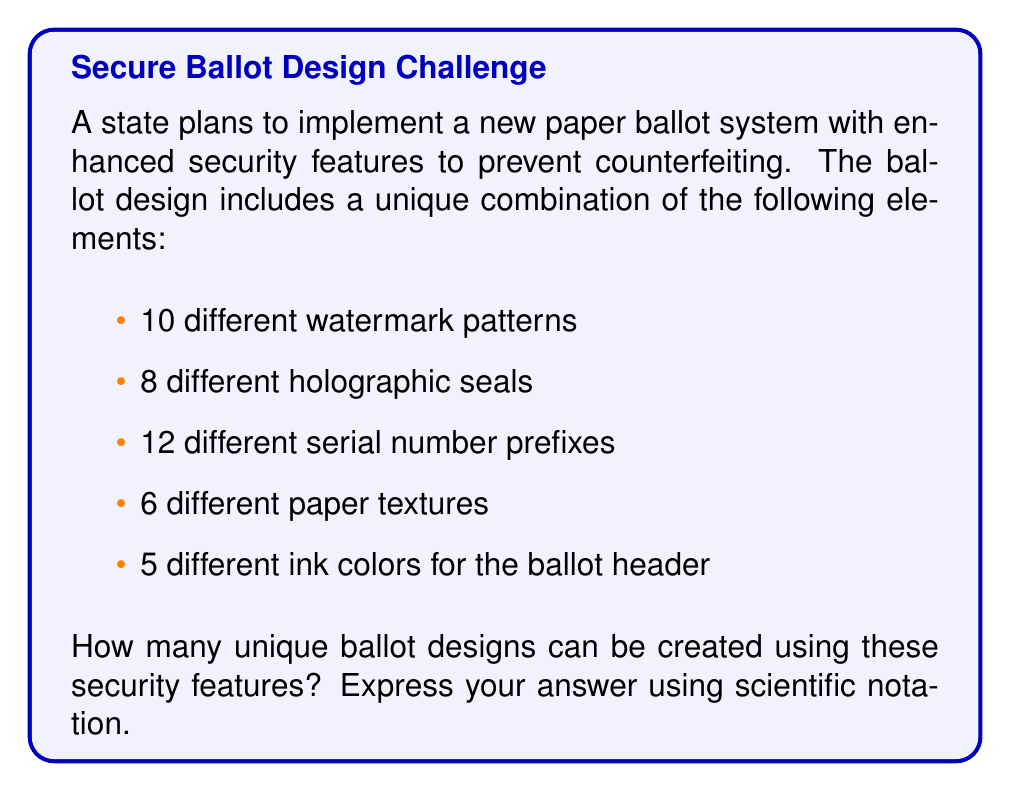Could you help me with this problem? To solve this problem, we'll use the multiplication principle of counting. Since each security feature can be chosen independently of the others, we multiply the number of options for each feature:

1. Number of watermark patterns: 10
2. Number of holographic seals: 8
3. Number of serial number prefixes: 12
4. Number of paper textures: 6
5. Number of ink colors for the header: 5

Total number of unique combinations:

$$ 10 \times 8 \times 12 \times 6 \times 5 = 28,800 $$

To express this in scientific notation:

$$ 28,800 = 2.88 \times 10^4 $$

This large number of unique combinations makes it extremely difficult for potential counterfeiters to replicate all possible ballot designs, thus enhancing the security and integrity of the paper-based voting system.
Answer: $2.88 \times 10^4$ 